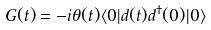<formula> <loc_0><loc_0><loc_500><loc_500>G ( t ) = - i \theta ( t ) \langle 0 | d ( t ) d ^ { \dagger } ( 0 ) | 0 \rangle</formula> 